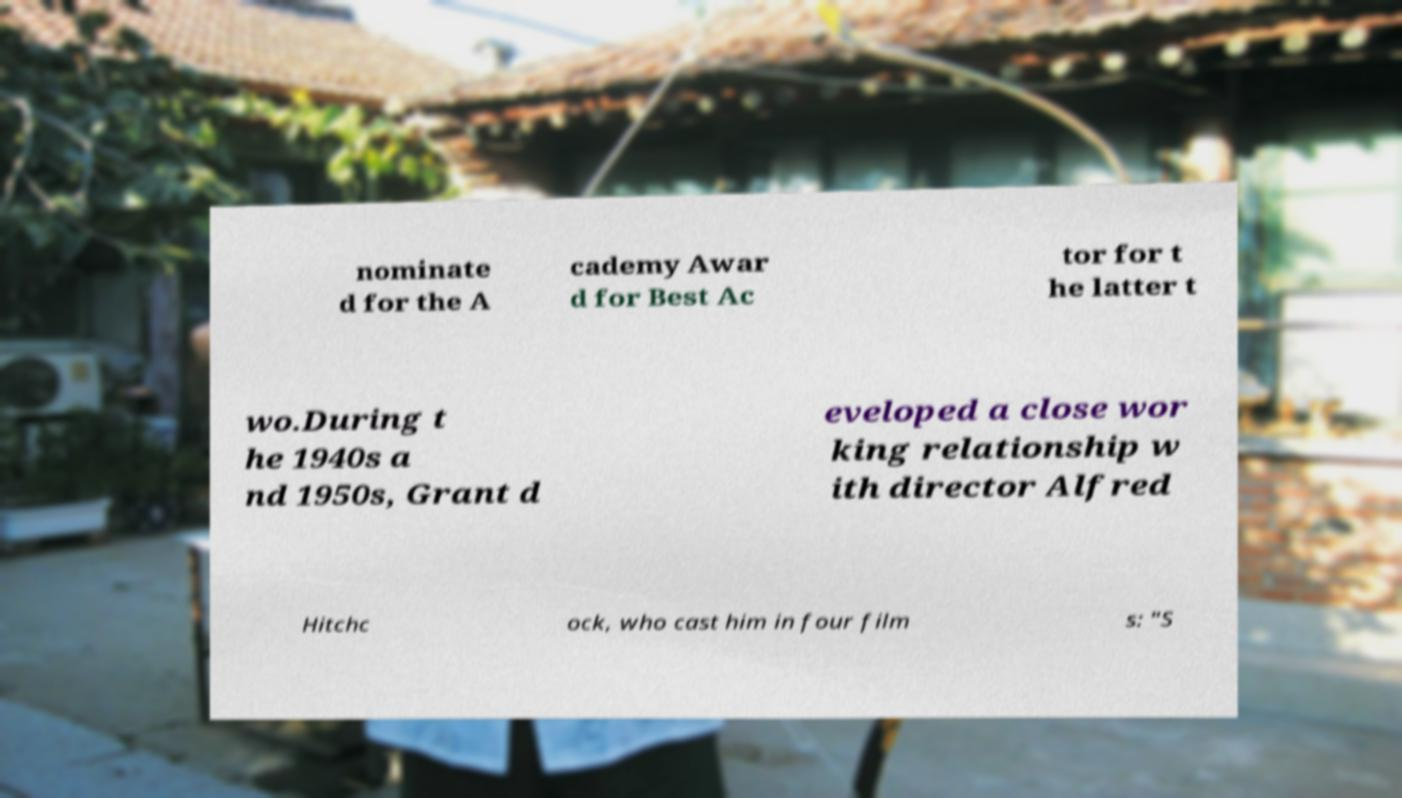Please read and relay the text visible in this image. What does it say? nominate d for the A cademy Awar d for Best Ac tor for t he latter t wo.During t he 1940s a nd 1950s, Grant d eveloped a close wor king relationship w ith director Alfred Hitchc ock, who cast him in four film s: "S 